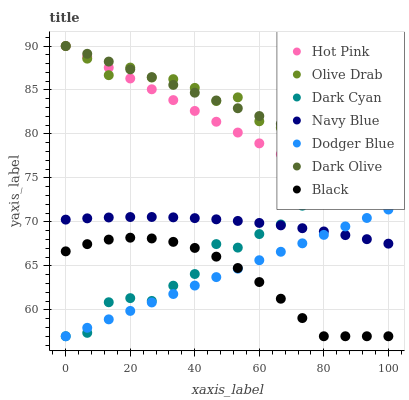Does Black have the minimum area under the curve?
Answer yes or no. Yes. Does Olive Drab have the maximum area under the curve?
Answer yes or no. Yes. Does Navy Blue have the minimum area under the curve?
Answer yes or no. No. Does Navy Blue have the maximum area under the curve?
Answer yes or no. No. Is Dodger Blue the smoothest?
Answer yes or no. Yes. Is Olive Drab the roughest?
Answer yes or no. Yes. Is Navy Blue the smoothest?
Answer yes or no. No. Is Navy Blue the roughest?
Answer yes or no. No. Does Dodger Blue have the lowest value?
Answer yes or no. Yes. Does Navy Blue have the lowest value?
Answer yes or no. No. Does Olive Drab have the highest value?
Answer yes or no. Yes. Does Navy Blue have the highest value?
Answer yes or no. No. Is Black less than Hot Pink?
Answer yes or no. Yes. Is Dark Olive greater than Black?
Answer yes or no. Yes. Does Hot Pink intersect Dark Cyan?
Answer yes or no. Yes. Is Hot Pink less than Dark Cyan?
Answer yes or no. No. Is Hot Pink greater than Dark Cyan?
Answer yes or no. No. Does Black intersect Hot Pink?
Answer yes or no. No. 